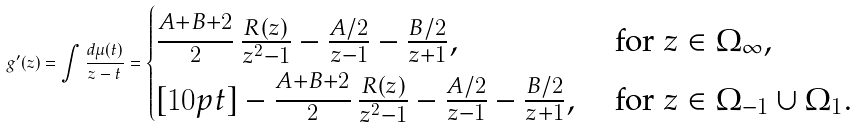Convert formula to latex. <formula><loc_0><loc_0><loc_500><loc_500>g ^ { \prime } ( z ) = \int \frac { d \mu ( t ) } { z - t } = \begin{cases} \frac { \strut A + B + 2 } { 2 } \, \frac { R ( z ) } { z ^ { 2 } - 1 } - \frac { A / 2 } { z - 1 } - \frac { B / 2 } { z + 1 } , & \text { for } z \in \Omega _ { \infty } , \\ [ 1 0 p t ] - \frac { \strut A + B + 2 } { 2 } \, \frac { R ( z ) } { z ^ { 2 } - 1 } - \frac { A / 2 } { z - 1 } - \frac { B / 2 } { z + 1 } , & \text { for } z \in \Omega _ { - 1 } \cup \Omega _ { 1 } . \end{cases}</formula> 